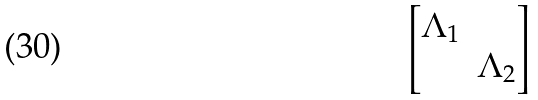<formula> <loc_0><loc_0><loc_500><loc_500>\begin{bmatrix} \Lambda _ { 1 } & \\ & \Lambda _ { 2 } \end{bmatrix}</formula> 